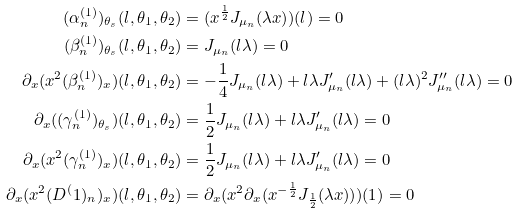Convert formula to latex. <formula><loc_0><loc_0><loc_500><loc_500>( \alpha ^ { ( 1 ) } _ { n } ) _ { \theta _ { s } } ( l , \theta _ { 1 } , \theta _ { 2 } ) & = ( x ^ { \frac { 1 } { 2 } } J _ { \mu _ { n } } ( \lambda x ) ) ( l ) = 0 \\ ( \beta ^ { ( 1 ) } _ { n } ) _ { \theta _ { s } } ( l , \theta _ { 1 } , \theta _ { 2 } ) & = J _ { \mu _ { n } } ( l \lambda ) = 0 \\ \partial _ { x } ( x ^ { 2 } ( \beta ^ { ( 1 ) } _ { n } ) _ { x } ) ( l , \theta _ { 1 } , \theta _ { 2 } ) & = - \frac { 1 } { 4 } J _ { \mu _ { n } } ( l \lambda ) + l \lambda J ^ { \prime } _ { \mu _ { n } } ( l \lambda ) + ( l \lambda ) ^ { 2 } J ^ { \prime \prime } _ { \mu _ { n } } ( l \lambda ) = 0 \\ \partial _ { x } ( ( \gamma ^ { ( 1 ) } _ { n } ) _ { \theta _ { s } } ) ( l , \theta _ { 1 } , \theta _ { 2 } ) & = \frac { 1 } { 2 } J _ { \mu _ { n } } ( l \lambda ) + l \lambda J ^ { \prime } _ { \mu _ { n } } ( l \lambda ) = 0 \\ \partial _ { x } ( x ^ { 2 } ( \gamma ^ { ( 1 ) } _ { n } ) _ { x } ) ( l , \theta _ { 1 } , \theta _ { 2 } ) & = \frac { 1 } { 2 } J _ { \mu _ { n } } ( l \lambda ) + l \lambda J ^ { \prime } _ { \mu _ { n } } ( l \lambda ) = 0 \\ \partial _ { x } ( x ^ { 2 } ( D ^ { ( } 1 ) _ { n } ) _ { x } ) ( l , \theta _ { 1 } , \theta _ { 2 } ) & = \partial _ { x } ( x ^ { 2 } \partial _ { x } ( x ^ { - \frac { 1 } { 2 } } J _ { \frac { 1 } { 2 } } ( \lambda x ) ) ) ( 1 ) = 0</formula> 